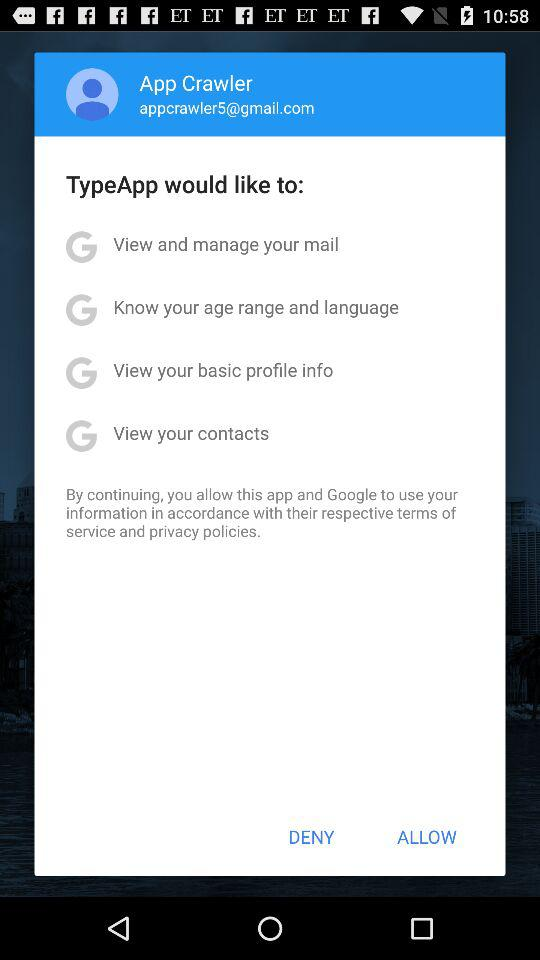What is the email address? The email address is appcrawler5@gmail.com. 